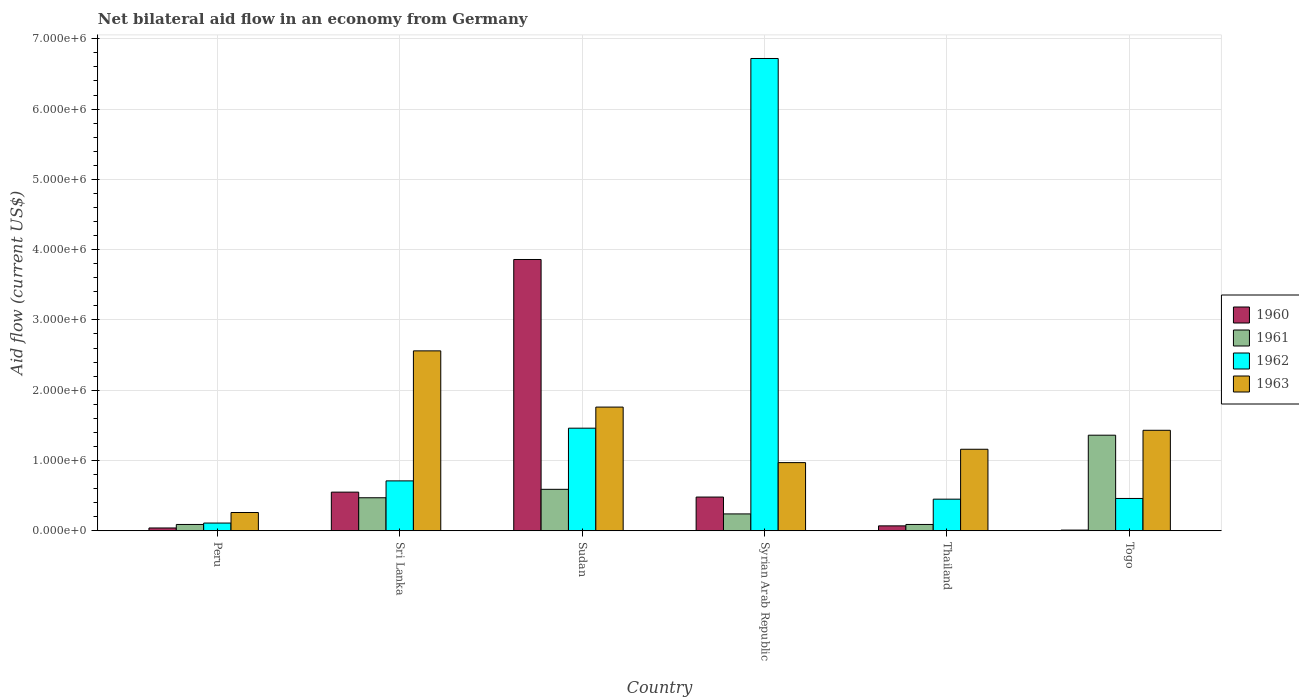Are the number of bars per tick equal to the number of legend labels?
Give a very brief answer. Yes. What is the label of the 4th group of bars from the left?
Provide a succinct answer. Syrian Arab Republic. In how many cases, is the number of bars for a given country not equal to the number of legend labels?
Your answer should be very brief. 0. What is the net bilateral aid flow in 1963 in Sudan?
Give a very brief answer. 1.76e+06. Across all countries, what is the maximum net bilateral aid flow in 1961?
Your response must be concise. 1.36e+06. Across all countries, what is the minimum net bilateral aid flow in 1961?
Provide a succinct answer. 9.00e+04. In which country was the net bilateral aid flow in 1962 maximum?
Offer a very short reply. Syrian Arab Republic. What is the total net bilateral aid flow in 1963 in the graph?
Ensure brevity in your answer.  8.14e+06. What is the difference between the net bilateral aid flow in 1962 in Peru and that in Syrian Arab Republic?
Provide a short and direct response. -6.61e+06. What is the difference between the net bilateral aid flow in 1962 in Sri Lanka and the net bilateral aid flow in 1963 in Togo?
Ensure brevity in your answer.  -7.20e+05. What is the average net bilateral aid flow in 1962 per country?
Make the answer very short. 1.65e+06. What is the difference between the net bilateral aid flow of/in 1963 and net bilateral aid flow of/in 1962 in Thailand?
Ensure brevity in your answer.  7.10e+05. What is the ratio of the net bilateral aid flow in 1961 in Peru to that in Togo?
Make the answer very short. 0.07. What is the difference between the highest and the second highest net bilateral aid flow in 1960?
Make the answer very short. 3.38e+06. What is the difference between the highest and the lowest net bilateral aid flow in 1962?
Provide a short and direct response. 6.61e+06. In how many countries, is the net bilateral aid flow in 1963 greater than the average net bilateral aid flow in 1963 taken over all countries?
Provide a succinct answer. 3. Is the sum of the net bilateral aid flow in 1963 in Sudan and Togo greater than the maximum net bilateral aid flow in 1962 across all countries?
Your answer should be very brief. No. Is it the case that in every country, the sum of the net bilateral aid flow in 1961 and net bilateral aid flow in 1963 is greater than the sum of net bilateral aid flow in 1960 and net bilateral aid flow in 1962?
Your answer should be very brief. No. What does the 2nd bar from the left in Togo represents?
Your response must be concise. 1961. What does the 2nd bar from the right in Togo represents?
Make the answer very short. 1962. How many bars are there?
Ensure brevity in your answer.  24. What is the difference between two consecutive major ticks on the Y-axis?
Your answer should be compact. 1.00e+06. Are the values on the major ticks of Y-axis written in scientific E-notation?
Ensure brevity in your answer.  Yes. Does the graph contain any zero values?
Ensure brevity in your answer.  No. Where does the legend appear in the graph?
Give a very brief answer. Center right. How many legend labels are there?
Offer a terse response. 4. How are the legend labels stacked?
Your answer should be compact. Vertical. What is the title of the graph?
Give a very brief answer. Net bilateral aid flow in an economy from Germany. Does "1977" appear as one of the legend labels in the graph?
Your response must be concise. No. What is the Aid flow (current US$) of 1960 in Peru?
Keep it short and to the point. 4.00e+04. What is the Aid flow (current US$) in 1962 in Peru?
Offer a terse response. 1.10e+05. What is the Aid flow (current US$) in 1961 in Sri Lanka?
Ensure brevity in your answer.  4.70e+05. What is the Aid flow (current US$) in 1962 in Sri Lanka?
Provide a succinct answer. 7.10e+05. What is the Aid flow (current US$) of 1963 in Sri Lanka?
Keep it short and to the point. 2.56e+06. What is the Aid flow (current US$) of 1960 in Sudan?
Ensure brevity in your answer.  3.86e+06. What is the Aid flow (current US$) of 1961 in Sudan?
Make the answer very short. 5.90e+05. What is the Aid flow (current US$) in 1962 in Sudan?
Your response must be concise. 1.46e+06. What is the Aid flow (current US$) in 1963 in Sudan?
Keep it short and to the point. 1.76e+06. What is the Aid flow (current US$) of 1961 in Syrian Arab Republic?
Your response must be concise. 2.40e+05. What is the Aid flow (current US$) of 1962 in Syrian Arab Republic?
Your answer should be very brief. 6.72e+06. What is the Aid flow (current US$) in 1963 in Syrian Arab Republic?
Provide a short and direct response. 9.70e+05. What is the Aid flow (current US$) in 1960 in Thailand?
Provide a succinct answer. 7.00e+04. What is the Aid flow (current US$) of 1963 in Thailand?
Your answer should be compact. 1.16e+06. What is the Aid flow (current US$) in 1961 in Togo?
Keep it short and to the point. 1.36e+06. What is the Aid flow (current US$) of 1962 in Togo?
Provide a succinct answer. 4.60e+05. What is the Aid flow (current US$) in 1963 in Togo?
Give a very brief answer. 1.43e+06. Across all countries, what is the maximum Aid flow (current US$) of 1960?
Ensure brevity in your answer.  3.86e+06. Across all countries, what is the maximum Aid flow (current US$) in 1961?
Your response must be concise. 1.36e+06. Across all countries, what is the maximum Aid flow (current US$) of 1962?
Offer a terse response. 6.72e+06. Across all countries, what is the maximum Aid flow (current US$) in 1963?
Provide a short and direct response. 2.56e+06. Across all countries, what is the minimum Aid flow (current US$) of 1961?
Your answer should be compact. 9.00e+04. Across all countries, what is the minimum Aid flow (current US$) in 1962?
Make the answer very short. 1.10e+05. Across all countries, what is the minimum Aid flow (current US$) of 1963?
Provide a succinct answer. 2.60e+05. What is the total Aid flow (current US$) in 1960 in the graph?
Your answer should be compact. 5.01e+06. What is the total Aid flow (current US$) in 1961 in the graph?
Your response must be concise. 2.84e+06. What is the total Aid flow (current US$) in 1962 in the graph?
Offer a very short reply. 9.91e+06. What is the total Aid flow (current US$) in 1963 in the graph?
Make the answer very short. 8.14e+06. What is the difference between the Aid flow (current US$) in 1960 in Peru and that in Sri Lanka?
Your answer should be compact. -5.10e+05. What is the difference between the Aid flow (current US$) in 1961 in Peru and that in Sri Lanka?
Your response must be concise. -3.80e+05. What is the difference between the Aid flow (current US$) in 1962 in Peru and that in Sri Lanka?
Provide a succinct answer. -6.00e+05. What is the difference between the Aid flow (current US$) in 1963 in Peru and that in Sri Lanka?
Provide a succinct answer. -2.30e+06. What is the difference between the Aid flow (current US$) of 1960 in Peru and that in Sudan?
Make the answer very short. -3.82e+06. What is the difference between the Aid flow (current US$) of 1961 in Peru and that in Sudan?
Offer a terse response. -5.00e+05. What is the difference between the Aid flow (current US$) of 1962 in Peru and that in Sudan?
Offer a terse response. -1.35e+06. What is the difference between the Aid flow (current US$) in 1963 in Peru and that in Sudan?
Keep it short and to the point. -1.50e+06. What is the difference between the Aid flow (current US$) in 1960 in Peru and that in Syrian Arab Republic?
Your response must be concise. -4.40e+05. What is the difference between the Aid flow (current US$) in 1962 in Peru and that in Syrian Arab Republic?
Keep it short and to the point. -6.61e+06. What is the difference between the Aid flow (current US$) of 1963 in Peru and that in Syrian Arab Republic?
Ensure brevity in your answer.  -7.10e+05. What is the difference between the Aid flow (current US$) in 1960 in Peru and that in Thailand?
Keep it short and to the point. -3.00e+04. What is the difference between the Aid flow (current US$) in 1963 in Peru and that in Thailand?
Offer a terse response. -9.00e+05. What is the difference between the Aid flow (current US$) in 1960 in Peru and that in Togo?
Keep it short and to the point. 3.00e+04. What is the difference between the Aid flow (current US$) of 1961 in Peru and that in Togo?
Make the answer very short. -1.27e+06. What is the difference between the Aid flow (current US$) of 1962 in Peru and that in Togo?
Provide a succinct answer. -3.50e+05. What is the difference between the Aid flow (current US$) of 1963 in Peru and that in Togo?
Provide a short and direct response. -1.17e+06. What is the difference between the Aid flow (current US$) in 1960 in Sri Lanka and that in Sudan?
Provide a succinct answer. -3.31e+06. What is the difference between the Aid flow (current US$) of 1962 in Sri Lanka and that in Sudan?
Keep it short and to the point. -7.50e+05. What is the difference between the Aid flow (current US$) of 1962 in Sri Lanka and that in Syrian Arab Republic?
Offer a very short reply. -6.01e+06. What is the difference between the Aid flow (current US$) of 1963 in Sri Lanka and that in Syrian Arab Republic?
Keep it short and to the point. 1.59e+06. What is the difference between the Aid flow (current US$) of 1962 in Sri Lanka and that in Thailand?
Your response must be concise. 2.60e+05. What is the difference between the Aid flow (current US$) of 1963 in Sri Lanka and that in Thailand?
Your answer should be compact. 1.40e+06. What is the difference between the Aid flow (current US$) of 1960 in Sri Lanka and that in Togo?
Your response must be concise. 5.40e+05. What is the difference between the Aid flow (current US$) of 1961 in Sri Lanka and that in Togo?
Keep it short and to the point. -8.90e+05. What is the difference between the Aid flow (current US$) of 1963 in Sri Lanka and that in Togo?
Offer a very short reply. 1.13e+06. What is the difference between the Aid flow (current US$) of 1960 in Sudan and that in Syrian Arab Republic?
Offer a terse response. 3.38e+06. What is the difference between the Aid flow (current US$) in 1961 in Sudan and that in Syrian Arab Republic?
Provide a succinct answer. 3.50e+05. What is the difference between the Aid flow (current US$) in 1962 in Sudan and that in Syrian Arab Republic?
Offer a very short reply. -5.26e+06. What is the difference between the Aid flow (current US$) of 1963 in Sudan and that in Syrian Arab Republic?
Ensure brevity in your answer.  7.90e+05. What is the difference between the Aid flow (current US$) in 1960 in Sudan and that in Thailand?
Your answer should be very brief. 3.79e+06. What is the difference between the Aid flow (current US$) of 1961 in Sudan and that in Thailand?
Make the answer very short. 5.00e+05. What is the difference between the Aid flow (current US$) in 1962 in Sudan and that in Thailand?
Your answer should be compact. 1.01e+06. What is the difference between the Aid flow (current US$) in 1960 in Sudan and that in Togo?
Keep it short and to the point. 3.85e+06. What is the difference between the Aid flow (current US$) in 1961 in Sudan and that in Togo?
Your response must be concise. -7.70e+05. What is the difference between the Aid flow (current US$) in 1962 in Sudan and that in Togo?
Give a very brief answer. 1.00e+06. What is the difference between the Aid flow (current US$) of 1961 in Syrian Arab Republic and that in Thailand?
Your answer should be very brief. 1.50e+05. What is the difference between the Aid flow (current US$) of 1962 in Syrian Arab Republic and that in Thailand?
Provide a short and direct response. 6.27e+06. What is the difference between the Aid flow (current US$) of 1963 in Syrian Arab Republic and that in Thailand?
Provide a short and direct response. -1.90e+05. What is the difference between the Aid flow (current US$) in 1961 in Syrian Arab Republic and that in Togo?
Your response must be concise. -1.12e+06. What is the difference between the Aid flow (current US$) in 1962 in Syrian Arab Republic and that in Togo?
Offer a very short reply. 6.26e+06. What is the difference between the Aid flow (current US$) in 1963 in Syrian Arab Republic and that in Togo?
Offer a very short reply. -4.60e+05. What is the difference between the Aid flow (current US$) of 1961 in Thailand and that in Togo?
Your answer should be compact. -1.27e+06. What is the difference between the Aid flow (current US$) of 1960 in Peru and the Aid flow (current US$) of 1961 in Sri Lanka?
Provide a succinct answer. -4.30e+05. What is the difference between the Aid flow (current US$) of 1960 in Peru and the Aid flow (current US$) of 1962 in Sri Lanka?
Offer a very short reply. -6.70e+05. What is the difference between the Aid flow (current US$) of 1960 in Peru and the Aid flow (current US$) of 1963 in Sri Lanka?
Offer a very short reply. -2.52e+06. What is the difference between the Aid flow (current US$) of 1961 in Peru and the Aid flow (current US$) of 1962 in Sri Lanka?
Make the answer very short. -6.20e+05. What is the difference between the Aid flow (current US$) of 1961 in Peru and the Aid flow (current US$) of 1963 in Sri Lanka?
Your answer should be very brief. -2.47e+06. What is the difference between the Aid flow (current US$) of 1962 in Peru and the Aid flow (current US$) of 1963 in Sri Lanka?
Your response must be concise. -2.45e+06. What is the difference between the Aid flow (current US$) in 1960 in Peru and the Aid flow (current US$) in 1961 in Sudan?
Your response must be concise. -5.50e+05. What is the difference between the Aid flow (current US$) in 1960 in Peru and the Aid flow (current US$) in 1962 in Sudan?
Your answer should be very brief. -1.42e+06. What is the difference between the Aid flow (current US$) of 1960 in Peru and the Aid flow (current US$) of 1963 in Sudan?
Your answer should be compact. -1.72e+06. What is the difference between the Aid flow (current US$) of 1961 in Peru and the Aid flow (current US$) of 1962 in Sudan?
Ensure brevity in your answer.  -1.37e+06. What is the difference between the Aid flow (current US$) of 1961 in Peru and the Aid flow (current US$) of 1963 in Sudan?
Your answer should be compact. -1.67e+06. What is the difference between the Aid flow (current US$) in 1962 in Peru and the Aid flow (current US$) in 1963 in Sudan?
Offer a terse response. -1.65e+06. What is the difference between the Aid flow (current US$) in 1960 in Peru and the Aid flow (current US$) in 1961 in Syrian Arab Republic?
Keep it short and to the point. -2.00e+05. What is the difference between the Aid flow (current US$) in 1960 in Peru and the Aid flow (current US$) in 1962 in Syrian Arab Republic?
Your response must be concise. -6.68e+06. What is the difference between the Aid flow (current US$) in 1960 in Peru and the Aid flow (current US$) in 1963 in Syrian Arab Republic?
Your response must be concise. -9.30e+05. What is the difference between the Aid flow (current US$) in 1961 in Peru and the Aid flow (current US$) in 1962 in Syrian Arab Republic?
Your answer should be very brief. -6.63e+06. What is the difference between the Aid flow (current US$) of 1961 in Peru and the Aid flow (current US$) of 1963 in Syrian Arab Republic?
Keep it short and to the point. -8.80e+05. What is the difference between the Aid flow (current US$) in 1962 in Peru and the Aid flow (current US$) in 1963 in Syrian Arab Republic?
Provide a short and direct response. -8.60e+05. What is the difference between the Aid flow (current US$) in 1960 in Peru and the Aid flow (current US$) in 1962 in Thailand?
Provide a short and direct response. -4.10e+05. What is the difference between the Aid flow (current US$) in 1960 in Peru and the Aid flow (current US$) in 1963 in Thailand?
Your answer should be very brief. -1.12e+06. What is the difference between the Aid flow (current US$) of 1961 in Peru and the Aid flow (current US$) of 1962 in Thailand?
Provide a succinct answer. -3.60e+05. What is the difference between the Aid flow (current US$) of 1961 in Peru and the Aid flow (current US$) of 1963 in Thailand?
Give a very brief answer. -1.07e+06. What is the difference between the Aid flow (current US$) of 1962 in Peru and the Aid flow (current US$) of 1963 in Thailand?
Provide a succinct answer. -1.05e+06. What is the difference between the Aid flow (current US$) of 1960 in Peru and the Aid flow (current US$) of 1961 in Togo?
Your response must be concise. -1.32e+06. What is the difference between the Aid flow (current US$) of 1960 in Peru and the Aid flow (current US$) of 1962 in Togo?
Offer a terse response. -4.20e+05. What is the difference between the Aid flow (current US$) of 1960 in Peru and the Aid flow (current US$) of 1963 in Togo?
Ensure brevity in your answer.  -1.39e+06. What is the difference between the Aid flow (current US$) of 1961 in Peru and the Aid flow (current US$) of 1962 in Togo?
Your response must be concise. -3.70e+05. What is the difference between the Aid flow (current US$) in 1961 in Peru and the Aid flow (current US$) in 1963 in Togo?
Keep it short and to the point. -1.34e+06. What is the difference between the Aid flow (current US$) of 1962 in Peru and the Aid flow (current US$) of 1963 in Togo?
Keep it short and to the point. -1.32e+06. What is the difference between the Aid flow (current US$) in 1960 in Sri Lanka and the Aid flow (current US$) in 1962 in Sudan?
Your answer should be compact. -9.10e+05. What is the difference between the Aid flow (current US$) in 1960 in Sri Lanka and the Aid flow (current US$) in 1963 in Sudan?
Provide a succinct answer. -1.21e+06. What is the difference between the Aid flow (current US$) in 1961 in Sri Lanka and the Aid flow (current US$) in 1962 in Sudan?
Give a very brief answer. -9.90e+05. What is the difference between the Aid flow (current US$) of 1961 in Sri Lanka and the Aid flow (current US$) of 1963 in Sudan?
Provide a short and direct response. -1.29e+06. What is the difference between the Aid flow (current US$) in 1962 in Sri Lanka and the Aid flow (current US$) in 1963 in Sudan?
Provide a succinct answer. -1.05e+06. What is the difference between the Aid flow (current US$) in 1960 in Sri Lanka and the Aid flow (current US$) in 1961 in Syrian Arab Republic?
Offer a terse response. 3.10e+05. What is the difference between the Aid flow (current US$) in 1960 in Sri Lanka and the Aid flow (current US$) in 1962 in Syrian Arab Republic?
Make the answer very short. -6.17e+06. What is the difference between the Aid flow (current US$) in 1960 in Sri Lanka and the Aid flow (current US$) in 1963 in Syrian Arab Republic?
Provide a succinct answer. -4.20e+05. What is the difference between the Aid flow (current US$) in 1961 in Sri Lanka and the Aid flow (current US$) in 1962 in Syrian Arab Republic?
Provide a short and direct response. -6.25e+06. What is the difference between the Aid flow (current US$) of 1961 in Sri Lanka and the Aid flow (current US$) of 1963 in Syrian Arab Republic?
Keep it short and to the point. -5.00e+05. What is the difference between the Aid flow (current US$) in 1962 in Sri Lanka and the Aid flow (current US$) in 1963 in Syrian Arab Republic?
Keep it short and to the point. -2.60e+05. What is the difference between the Aid flow (current US$) of 1960 in Sri Lanka and the Aid flow (current US$) of 1963 in Thailand?
Provide a succinct answer. -6.10e+05. What is the difference between the Aid flow (current US$) in 1961 in Sri Lanka and the Aid flow (current US$) in 1962 in Thailand?
Offer a terse response. 2.00e+04. What is the difference between the Aid flow (current US$) of 1961 in Sri Lanka and the Aid flow (current US$) of 1963 in Thailand?
Your answer should be compact. -6.90e+05. What is the difference between the Aid flow (current US$) of 1962 in Sri Lanka and the Aid flow (current US$) of 1963 in Thailand?
Offer a very short reply. -4.50e+05. What is the difference between the Aid flow (current US$) of 1960 in Sri Lanka and the Aid flow (current US$) of 1961 in Togo?
Give a very brief answer. -8.10e+05. What is the difference between the Aid flow (current US$) in 1960 in Sri Lanka and the Aid flow (current US$) in 1962 in Togo?
Give a very brief answer. 9.00e+04. What is the difference between the Aid flow (current US$) of 1960 in Sri Lanka and the Aid flow (current US$) of 1963 in Togo?
Your response must be concise. -8.80e+05. What is the difference between the Aid flow (current US$) in 1961 in Sri Lanka and the Aid flow (current US$) in 1963 in Togo?
Give a very brief answer. -9.60e+05. What is the difference between the Aid flow (current US$) in 1962 in Sri Lanka and the Aid flow (current US$) in 1963 in Togo?
Provide a short and direct response. -7.20e+05. What is the difference between the Aid flow (current US$) of 1960 in Sudan and the Aid flow (current US$) of 1961 in Syrian Arab Republic?
Your response must be concise. 3.62e+06. What is the difference between the Aid flow (current US$) of 1960 in Sudan and the Aid flow (current US$) of 1962 in Syrian Arab Republic?
Keep it short and to the point. -2.86e+06. What is the difference between the Aid flow (current US$) of 1960 in Sudan and the Aid flow (current US$) of 1963 in Syrian Arab Republic?
Make the answer very short. 2.89e+06. What is the difference between the Aid flow (current US$) in 1961 in Sudan and the Aid flow (current US$) in 1962 in Syrian Arab Republic?
Your answer should be very brief. -6.13e+06. What is the difference between the Aid flow (current US$) of 1961 in Sudan and the Aid flow (current US$) of 1963 in Syrian Arab Republic?
Provide a short and direct response. -3.80e+05. What is the difference between the Aid flow (current US$) of 1960 in Sudan and the Aid flow (current US$) of 1961 in Thailand?
Provide a succinct answer. 3.77e+06. What is the difference between the Aid flow (current US$) of 1960 in Sudan and the Aid flow (current US$) of 1962 in Thailand?
Provide a short and direct response. 3.41e+06. What is the difference between the Aid flow (current US$) of 1960 in Sudan and the Aid flow (current US$) of 1963 in Thailand?
Keep it short and to the point. 2.70e+06. What is the difference between the Aid flow (current US$) in 1961 in Sudan and the Aid flow (current US$) in 1963 in Thailand?
Your answer should be compact. -5.70e+05. What is the difference between the Aid flow (current US$) in 1962 in Sudan and the Aid flow (current US$) in 1963 in Thailand?
Provide a short and direct response. 3.00e+05. What is the difference between the Aid flow (current US$) of 1960 in Sudan and the Aid flow (current US$) of 1961 in Togo?
Your answer should be very brief. 2.50e+06. What is the difference between the Aid flow (current US$) of 1960 in Sudan and the Aid flow (current US$) of 1962 in Togo?
Provide a succinct answer. 3.40e+06. What is the difference between the Aid flow (current US$) of 1960 in Sudan and the Aid flow (current US$) of 1963 in Togo?
Offer a terse response. 2.43e+06. What is the difference between the Aid flow (current US$) in 1961 in Sudan and the Aid flow (current US$) in 1963 in Togo?
Ensure brevity in your answer.  -8.40e+05. What is the difference between the Aid flow (current US$) in 1960 in Syrian Arab Republic and the Aid flow (current US$) in 1962 in Thailand?
Your answer should be compact. 3.00e+04. What is the difference between the Aid flow (current US$) in 1960 in Syrian Arab Republic and the Aid flow (current US$) in 1963 in Thailand?
Offer a terse response. -6.80e+05. What is the difference between the Aid flow (current US$) of 1961 in Syrian Arab Republic and the Aid flow (current US$) of 1963 in Thailand?
Offer a terse response. -9.20e+05. What is the difference between the Aid flow (current US$) of 1962 in Syrian Arab Republic and the Aid flow (current US$) of 1963 in Thailand?
Keep it short and to the point. 5.56e+06. What is the difference between the Aid flow (current US$) of 1960 in Syrian Arab Republic and the Aid flow (current US$) of 1961 in Togo?
Provide a succinct answer. -8.80e+05. What is the difference between the Aid flow (current US$) in 1960 in Syrian Arab Republic and the Aid flow (current US$) in 1963 in Togo?
Your answer should be compact. -9.50e+05. What is the difference between the Aid flow (current US$) in 1961 in Syrian Arab Republic and the Aid flow (current US$) in 1962 in Togo?
Give a very brief answer. -2.20e+05. What is the difference between the Aid flow (current US$) in 1961 in Syrian Arab Republic and the Aid flow (current US$) in 1963 in Togo?
Give a very brief answer. -1.19e+06. What is the difference between the Aid flow (current US$) of 1962 in Syrian Arab Republic and the Aid flow (current US$) of 1963 in Togo?
Provide a succinct answer. 5.29e+06. What is the difference between the Aid flow (current US$) of 1960 in Thailand and the Aid flow (current US$) of 1961 in Togo?
Make the answer very short. -1.29e+06. What is the difference between the Aid flow (current US$) of 1960 in Thailand and the Aid flow (current US$) of 1962 in Togo?
Ensure brevity in your answer.  -3.90e+05. What is the difference between the Aid flow (current US$) of 1960 in Thailand and the Aid flow (current US$) of 1963 in Togo?
Make the answer very short. -1.36e+06. What is the difference between the Aid flow (current US$) of 1961 in Thailand and the Aid flow (current US$) of 1962 in Togo?
Provide a short and direct response. -3.70e+05. What is the difference between the Aid flow (current US$) in 1961 in Thailand and the Aid flow (current US$) in 1963 in Togo?
Provide a succinct answer. -1.34e+06. What is the difference between the Aid flow (current US$) in 1962 in Thailand and the Aid flow (current US$) in 1963 in Togo?
Your response must be concise. -9.80e+05. What is the average Aid flow (current US$) of 1960 per country?
Your answer should be compact. 8.35e+05. What is the average Aid flow (current US$) of 1961 per country?
Offer a terse response. 4.73e+05. What is the average Aid flow (current US$) in 1962 per country?
Keep it short and to the point. 1.65e+06. What is the average Aid flow (current US$) in 1963 per country?
Your response must be concise. 1.36e+06. What is the difference between the Aid flow (current US$) of 1960 and Aid flow (current US$) of 1962 in Peru?
Make the answer very short. -7.00e+04. What is the difference between the Aid flow (current US$) in 1960 and Aid flow (current US$) in 1963 in Peru?
Your answer should be very brief. -2.20e+05. What is the difference between the Aid flow (current US$) of 1961 and Aid flow (current US$) of 1962 in Peru?
Your response must be concise. -2.00e+04. What is the difference between the Aid flow (current US$) in 1961 and Aid flow (current US$) in 1963 in Peru?
Provide a short and direct response. -1.70e+05. What is the difference between the Aid flow (current US$) in 1960 and Aid flow (current US$) in 1963 in Sri Lanka?
Make the answer very short. -2.01e+06. What is the difference between the Aid flow (current US$) in 1961 and Aid flow (current US$) in 1963 in Sri Lanka?
Provide a succinct answer. -2.09e+06. What is the difference between the Aid flow (current US$) of 1962 and Aid flow (current US$) of 1963 in Sri Lanka?
Your answer should be compact. -1.85e+06. What is the difference between the Aid flow (current US$) of 1960 and Aid flow (current US$) of 1961 in Sudan?
Ensure brevity in your answer.  3.27e+06. What is the difference between the Aid flow (current US$) of 1960 and Aid flow (current US$) of 1962 in Sudan?
Ensure brevity in your answer.  2.40e+06. What is the difference between the Aid flow (current US$) of 1960 and Aid flow (current US$) of 1963 in Sudan?
Offer a terse response. 2.10e+06. What is the difference between the Aid flow (current US$) in 1961 and Aid flow (current US$) in 1962 in Sudan?
Your response must be concise. -8.70e+05. What is the difference between the Aid flow (current US$) in 1961 and Aid flow (current US$) in 1963 in Sudan?
Offer a very short reply. -1.17e+06. What is the difference between the Aid flow (current US$) in 1960 and Aid flow (current US$) in 1961 in Syrian Arab Republic?
Your response must be concise. 2.40e+05. What is the difference between the Aid flow (current US$) in 1960 and Aid flow (current US$) in 1962 in Syrian Arab Republic?
Your answer should be very brief. -6.24e+06. What is the difference between the Aid flow (current US$) in 1960 and Aid flow (current US$) in 1963 in Syrian Arab Republic?
Make the answer very short. -4.90e+05. What is the difference between the Aid flow (current US$) of 1961 and Aid flow (current US$) of 1962 in Syrian Arab Republic?
Give a very brief answer. -6.48e+06. What is the difference between the Aid flow (current US$) of 1961 and Aid flow (current US$) of 1963 in Syrian Arab Republic?
Keep it short and to the point. -7.30e+05. What is the difference between the Aid flow (current US$) of 1962 and Aid flow (current US$) of 1963 in Syrian Arab Republic?
Offer a terse response. 5.75e+06. What is the difference between the Aid flow (current US$) in 1960 and Aid flow (current US$) in 1961 in Thailand?
Offer a terse response. -2.00e+04. What is the difference between the Aid flow (current US$) in 1960 and Aid flow (current US$) in 1962 in Thailand?
Keep it short and to the point. -3.80e+05. What is the difference between the Aid flow (current US$) of 1960 and Aid flow (current US$) of 1963 in Thailand?
Provide a short and direct response. -1.09e+06. What is the difference between the Aid flow (current US$) in 1961 and Aid flow (current US$) in 1962 in Thailand?
Ensure brevity in your answer.  -3.60e+05. What is the difference between the Aid flow (current US$) of 1961 and Aid flow (current US$) of 1963 in Thailand?
Keep it short and to the point. -1.07e+06. What is the difference between the Aid flow (current US$) of 1962 and Aid flow (current US$) of 1963 in Thailand?
Offer a terse response. -7.10e+05. What is the difference between the Aid flow (current US$) in 1960 and Aid flow (current US$) in 1961 in Togo?
Provide a short and direct response. -1.35e+06. What is the difference between the Aid flow (current US$) in 1960 and Aid flow (current US$) in 1962 in Togo?
Offer a terse response. -4.50e+05. What is the difference between the Aid flow (current US$) of 1960 and Aid flow (current US$) of 1963 in Togo?
Provide a short and direct response. -1.42e+06. What is the difference between the Aid flow (current US$) in 1962 and Aid flow (current US$) in 1963 in Togo?
Provide a succinct answer. -9.70e+05. What is the ratio of the Aid flow (current US$) in 1960 in Peru to that in Sri Lanka?
Give a very brief answer. 0.07. What is the ratio of the Aid flow (current US$) of 1961 in Peru to that in Sri Lanka?
Offer a very short reply. 0.19. What is the ratio of the Aid flow (current US$) of 1962 in Peru to that in Sri Lanka?
Ensure brevity in your answer.  0.15. What is the ratio of the Aid flow (current US$) of 1963 in Peru to that in Sri Lanka?
Give a very brief answer. 0.1. What is the ratio of the Aid flow (current US$) in 1960 in Peru to that in Sudan?
Provide a succinct answer. 0.01. What is the ratio of the Aid flow (current US$) in 1961 in Peru to that in Sudan?
Ensure brevity in your answer.  0.15. What is the ratio of the Aid flow (current US$) in 1962 in Peru to that in Sudan?
Your answer should be very brief. 0.08. What is the ratio of the Aid flow (current US$) of 1963 in Peru to that in Sudan?
Offer a terse response. 0.15. What is the ratio of the Aid flow (current US$) in 1960 in Peru to that in Syrian Arab Republic?
Provide a succinct answer. 0.08. What is the ratio of the Aid flow (current US$) of 1961 in Peru to that in Syrian Arab Republic?
Ensure brevity in your answer.  0.38. What is the ratio of the Aid flow (current US$) of 1962 in Peru to that in Syrian Arab Republic?
Give a very brief answer. 0.02. What is the ratio of the Aid flow (current US$) in 1963 in Peru to that in Syrian Arab Republic?
Offer a very short reply. 0.27. What is the ratio of the Aid flow (current US$) of 1960 in Peru to that in Thailand?
Keep it short and to the point. 0.57. What is the ratio of the Aid flow (current US$) of 1961 in Peru to that in Thailand?
Your answer should be very brief. 1. What is the ratio of the Aid flow (current US$) of 1962 in Peru to that in Thailand?
Provide a short and direct response. 0.24. What is the ratio of the Aid flow (current US$) of 1963 in Peru to that in Thailand?
Make the answer very short. 0.22. What is the ratio of the Aid flow (current US$) in 1961 in Peru to that in Togo?
Offer a terse response. 0.07. What is the ratio of the Aid flow (current US$) of 1962 in Peru to that in Togo?
Make the answer very short. 0.24. What is the ratio of the Aid flow (current US$) in 1963 in Peru to that in Togo?
Provide a succinct answer. 0.18. What is the ratio of the Aid flow (current US$) in 1960 in Sri Lanka to that in Sudan?
Ensure brevity in your answer.  0.14. What is the ratio of the Aid flow (current US$) in 1961 in Sri Lanka to that in Sudan?
Your answer should be compact. 0.8. What is the ratio of the Aid flow (current US$) in 1962 in Sri Lanka to that in Sudan?
Give a very brief answer. 0.49. What is the ratio of the Aid flow (current US$) of 1963 in Sri Lanka to that in Sudan?
Ensure brevity in your answer.  1.45. What is the ratio of the Aid flow (current US$) in 1960 in Sri Lanka to that in Syrian Arab Republic?
Give a very brief answer. 1.15. What is the ratio of the Aid flow (current US$) in 1961 in Sri Lanka to that in Syrian Arab Republic?
Ensure brevity in your answer.  1.96. What is the ratio of the Aid flow (current US$) in 1962 in Sri Lanka to that in Syrian Arab Republic?
Your response must be concise. 0.11. What is the ratio of the Aid flow (current US$) of 1963 in Sri Lanka to that in Syrian Arab Republic?
Keep it short and to the point. 2.64. What is the ratio of the Aid flow (current US$) in 1960 in Sri Lanka to that in Thailand?
Offer a terse response. 7.86. What is the ratio of the Aid flow (current US$) in 1961 in Sri Lanka to that in Thailand?
Offer a very short reply. 5.22. What is the ratio of the Aid flow (current US$) of 1962 in Sri Lanka to that in Thailand?
Your answer should be very brief. 1.58. What is the ratio of the Aid flow (current US$) of 1963 in Sri Lanka to that in Thailand?
Your answer should be compact. 2.21. What is the ratio of the Aid flow (current US$) of 1961 in Sri Lanka to that in Togo?
Ensure brevity in your answer.  0.35. What is the ratio of the Aid flow (current US$) in 1962 in Sri Lanka to that in Togo?
Provide a succinct answer. 1.54. What is the ratio of the Aid flow (current US$) of 1963 in Sri Lanka to that in Togo?
Provide a short and direct response. 1.79. What is the ratio of the Aid flow (current US$) of 1960 in Sudan to that in Syrian Arab Republic?
Your answer should be compact. 8.04. What is the ratio of the Aid flow (current US$) in 1961 in Sudan to that in Syrian Arab Republic?
Provide a succinct answer. 2.46. What is the ratio of the Aid flow (current US$) in 1962 in Sudan to that in Syrian Arab Republic?
Your answer should be compact. 0.22. What is the ratio of the Aid flow (current US$) of 1963 in Sudan to that in Syrian Arab Republic?
Ensure brevity in your answer.  1.81. What is the ratio of the Aid flow (current US$) of 1960 in Sudan to that in Thailand?
Your response must be concise. 55.14. What is the ratio of the Aid flow (current US$) in 1961 in Sudan to that in Thailand?
Keep it short and to the point. 6.56. What is the ratio of the Aid flow (current US$) of 1962 in Sudan to that in Thailand?
Keep it short and to the point. 3.24. What is the ratio of the Aid flow (current US$) in 1963 in Sudan to that in Thailand?
Make the answer very short. 1.52. What is the ratio of the Aid flow (current US$) in 1960 in Sudan to that in Togo?
Keep it short and to the point. 386. What is the ratio of the Aid flow (current US$) in 1961 in Sudan to that in Togo?
Provide a short and direct response. 0.43. What is the ratio of the Aid flow (current US$) in 1962 in Sudan to that in Togo?
Make the answer very short. 3.17. What is the ratio of the Aid flow (current US$) in 1963 in Sudan to that in Togo?
Provide a succinct answer. 1.23. What is the ratio of the Aid flow (current US$) in 1960 in Syrian Arab Republic to that in Thailand?
Give a very brief answer. 6.86. What is the ratio of the Aid flow (current US$) in 1961 in Syrian Arab Republic to that in Thailand?
Your response must be concise. 2.67. What is the ratio of the Aid flow (current US$) of 1962 in Syrian Arab Republic to that in Thailand?
Keep it short and to the point. 14.93. What is the ratio of the Aid flow (current US$) of 1963 in Syrian Arab Republic to that in Thailand?
Give a very brief answer. 0.84. What is the ratio of the Aid flow (current US$) in 1961 in Syrian Arab Republic to that in Togo?
Provide a short and direct response. 0.18. What is the ratio of the Aid flow (current US$) of 1962 in Syrian Arab Republic to that in Togo?
Keep it short and to the point. 14.61. What is the ratio of the Aid flow (current US$) of 1963 in Syrian Arab Republic to that in Togo?
Your answer should be compact. 0.68. What is the ratio of the Aid flow (current US$) of 1960 in Thailand to that in Togo?
Give a very brief answer. 7. What is the ratio of the Aid flow (current US$) in 1961 in Thailand to that in Togo?
Keep it short and to the point. 0.07. What is the ratio of the Aid flow (current US$) of 1962 in Thailand to that in Togo?
Keep it short and to the point. 0.98. What is the ratio of the Aid flow (current US$) of 1963 in Thailand to that in Togo?
Provide a short and direct response. 0.81. What is the difference between the highest and the second highest Aid flow (current US$) in 1960?
Keep it short and to the point. 3.31e+06. What is the difference between the highest and the second highest Aid flow (current US$) in 1961?
Provide a succinct answer. 7.70e+05. What is the difference between the highest and the second highest Aid flow (current US$) in 1962?
Ensure brevity in your answer.  5.26e+06. What is the difference between the highest and the lowest Aid flow (current US$) in 1960?
Offer a very short reply. 3.85e+06. What is the difference between the highest and the lowest Aid flow (current US$) in 1961?
Ensure brevity in your answer.  1.27e+06. What is the difference between the highest and the lowest Aid flow (current US$) in 1962?
Provide a succinct answer. 6.61e+06. What is the difference between the highest and the lowest Aid flow (current US$) in 1963?
Your response must be concise. 2.30e+06. 